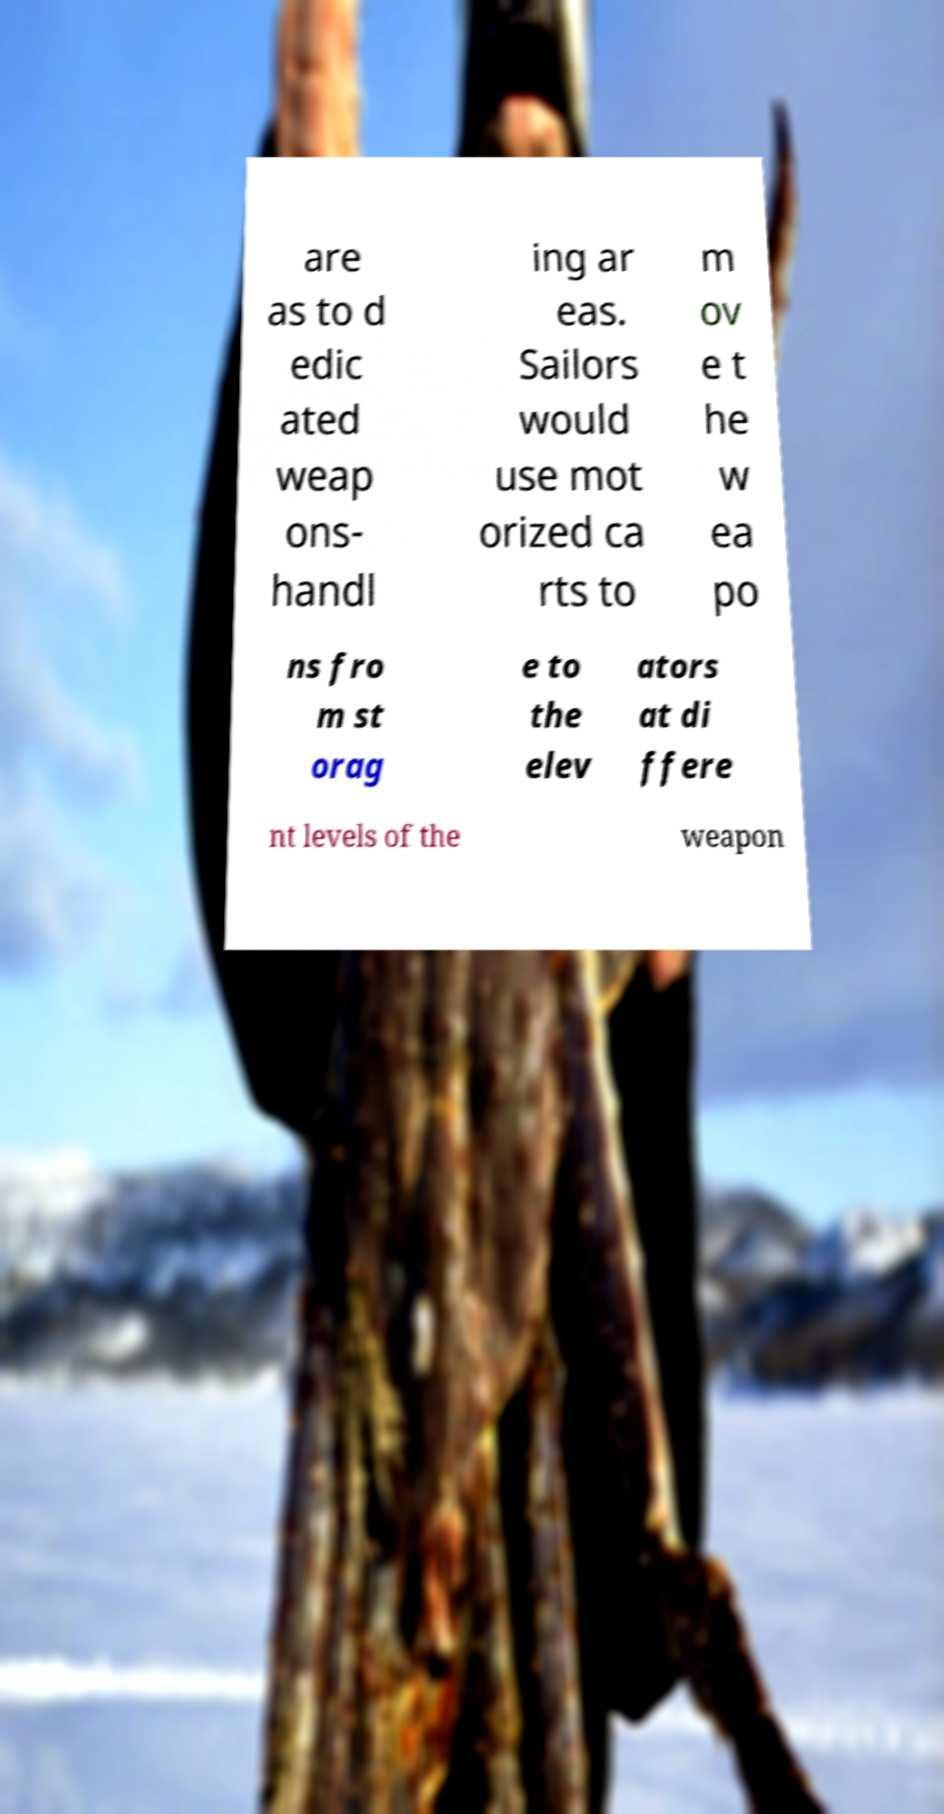Please read and relay the text visible in this image. What does it say? are as to d edic ated weap ons- handl ing ar eas. Sailors would use mot orized ca rts to m ov e t he w ea po ns fro m st orag e to the elev ators at di ffere nt levels of the weapon 